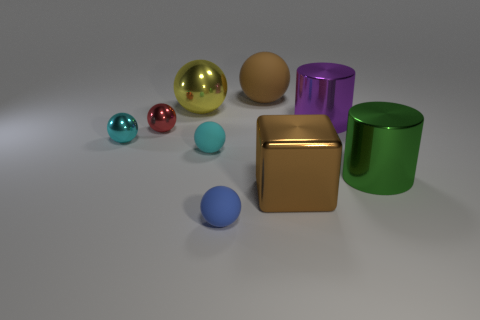Subtract all cyan balls. How many balls are left? 4 Subtract all large yellow balls. How many balls are left? 5 Subtract all yellow spheres. Subtract all green cylinders. How many spheres are left? 5 Add 1 big brown rubber balls. How many objects exist? 10 Subtract all spheres. How many objects are left? 3 Subtract 0 blue cylinders. How many objects are left? 9 Subtract all large purple cylinders. Subtract all gray metallic objects. How many objects are left? 8 Add 4 brown things. How many brown things are left? 6 Add 9 large cubes. How many large cubes exist? 10 